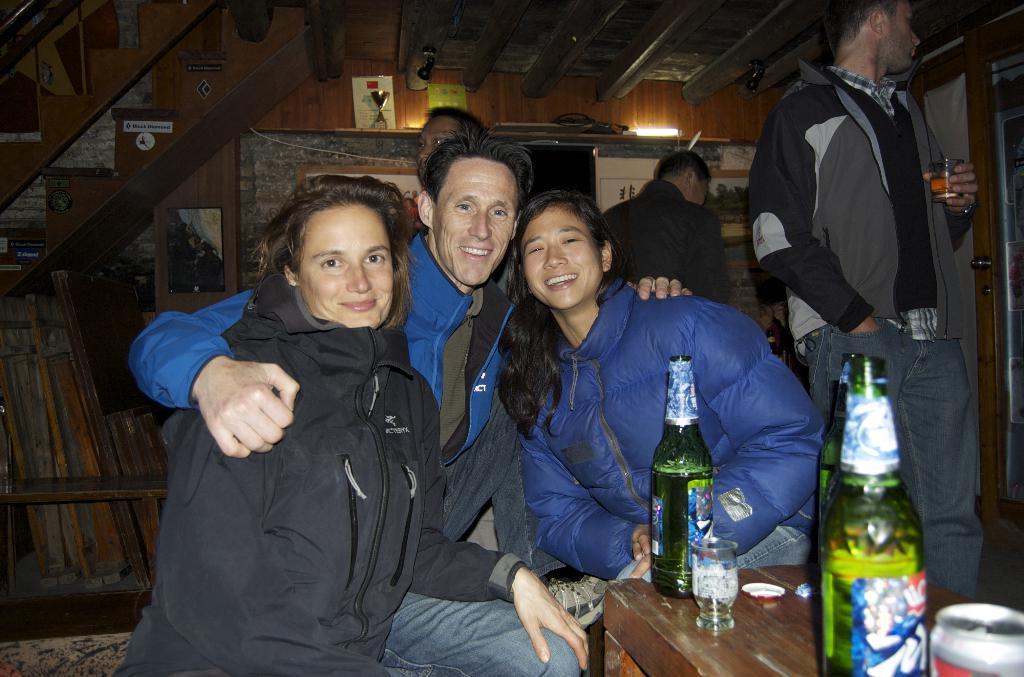Describe this image in one or two sentences. As we can see in the image there are few people standing and sitting and there is a table on the right side. On table there are glasses and bottles. 